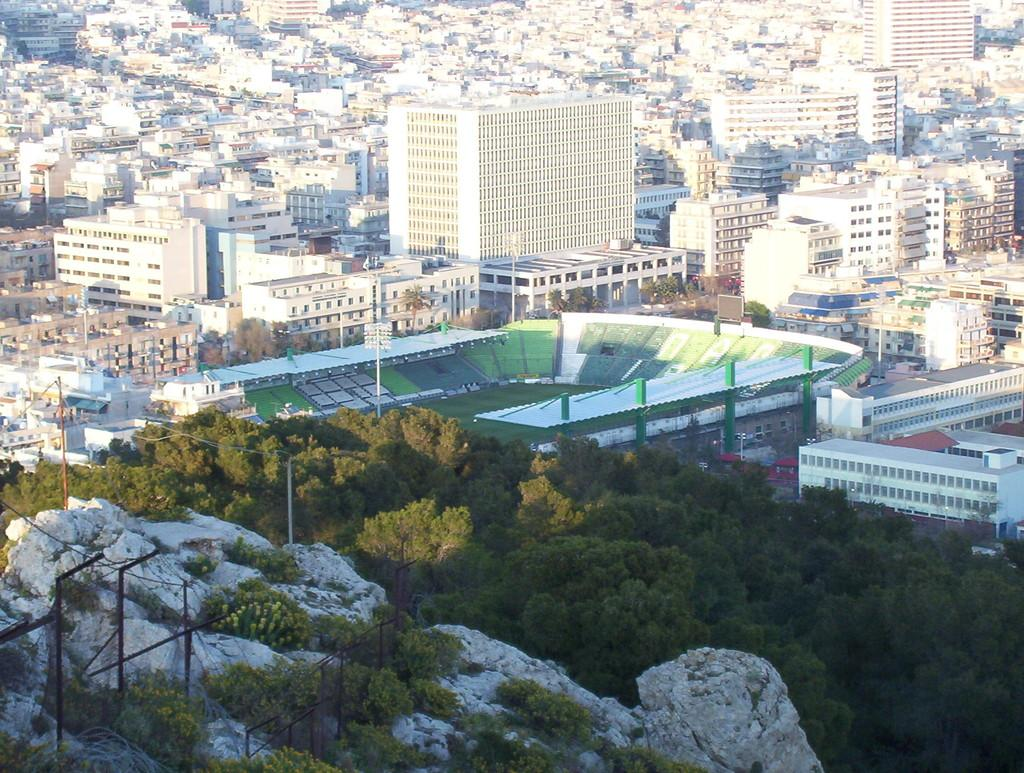What type of natural elements can be seen in the image? There are many trees in the image. What type of man-made structures can be seen in the image? There are many buildings in the image. What type of skin condition can be seen on the trees in the image? There is no mention of any skin condition on the trees in the image. The trees appear to be healthy and normal. 